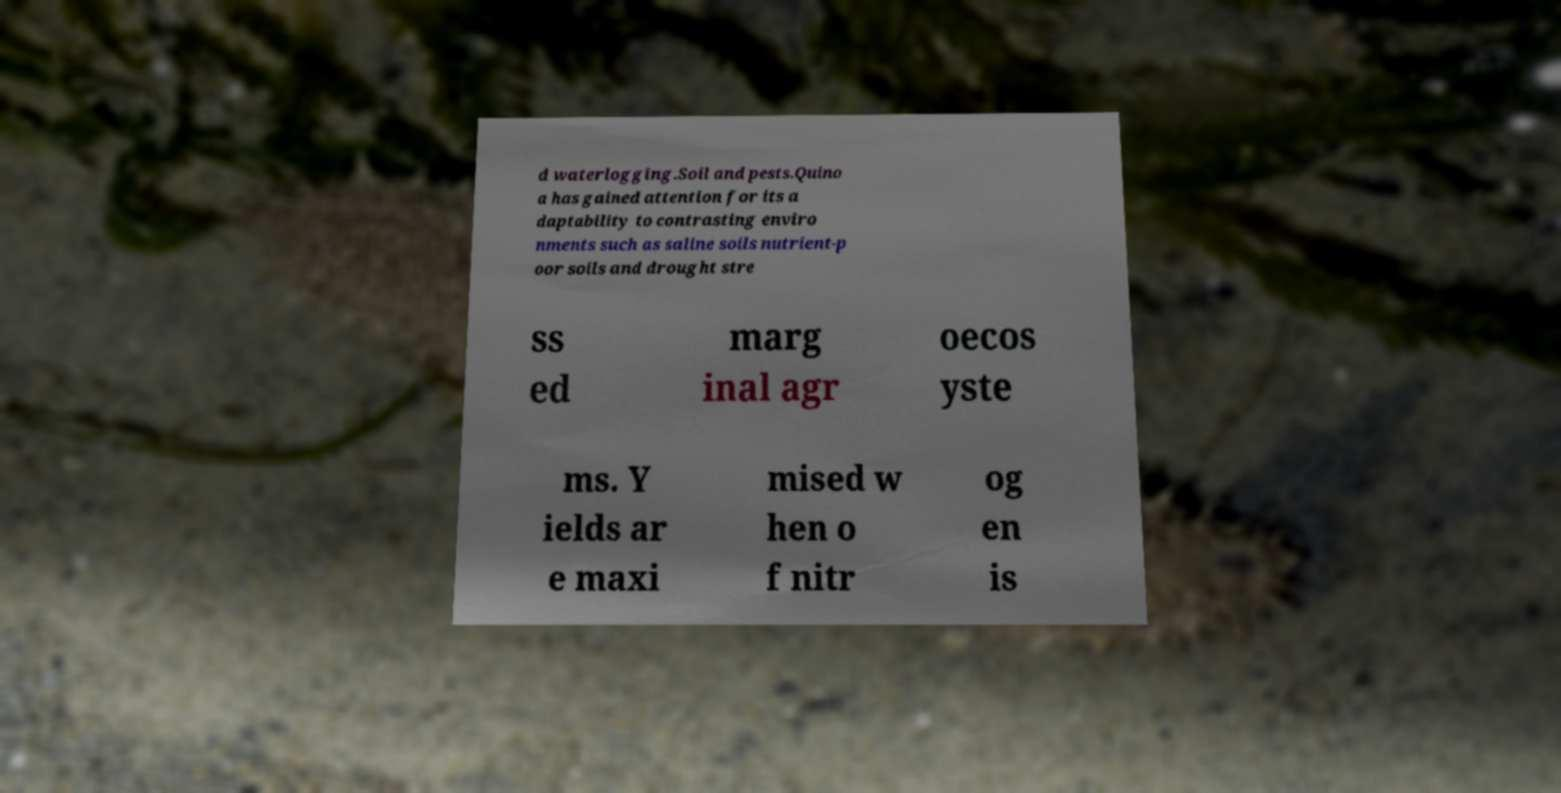I need the written content from this picture converted into text. Can you do that? d waterlogging.Soil and pests.Quino a has gained attention for its a daptability to contrasting enviro nments such as saline soils nutrient-p oor soils and drought stre ss ed marg inal agr oecos yste ms. Y ields ar e maxi mised w hen o f nitr og en is 